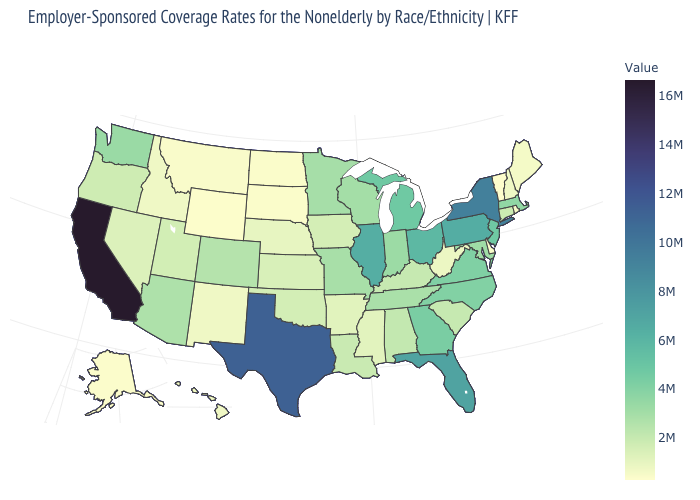Does South Dakota have the lowest value in the MidWest?
Short answer required. Yes. Which states have the lowest value in the West?
Be succinct. Wyoming. Does Oklahoma have a higher value than Ohio?
Quick response, please. No. 